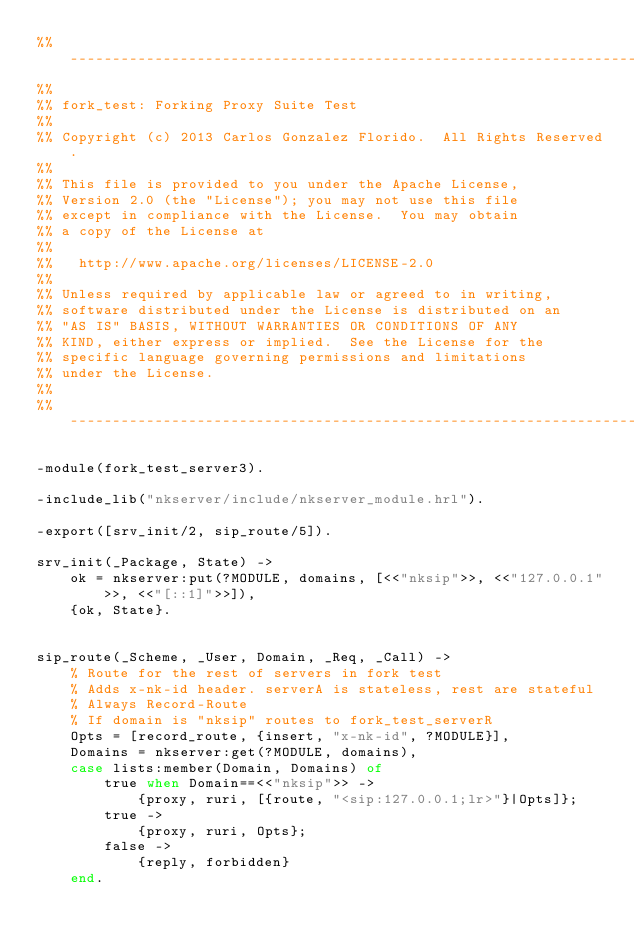Convert code to text. <code><loc_0><loc_0><loc_500><loc_500><_Erlang_>%% -------------------------------------------------------------------
%%
%% fork_test: Forking Proxy Suite Test
%%
%% Copyright (c) 2013 Carlos Gonzalez Florido.  All Rights Reserved.
%%
%% This file is provided to you under the Apache License,
%% Version 2.0 (the "License"); you may not use this file
%% except in compliance with the License.  You may obtain
%% a copy of the License at
%%
%%   http://www.apache.org/licenses/LICENSE-2.0
%%
%% Unless required by applicable law or agreed to in writing,
%% software distributed under the License is distributed on an
%% "AS IS" BASIS, WITHOUT WARRANTIES OR CONDITIONS OF ANY
%% KIND, either express or implied.  See the License for the
%% specific language governing permissions and limitations
%% under the License.
%%
%% -------------------------------------------------------------------

-module(fork_test_server3).

-include_lib("nkserver/include/nkserver_module.hrl").

-export([srv_init/2, sip_route/5]).

srv_init(_Package, State) ->
    ok = nkserver:put(?MODULE, domains, [<<"nksip">>, <<"127.0.0.1">>, <<"[::1]">>]),
    {ok, State}.


sip_route(_Scheme, _User, Domain, _Req, _Call) ->
    % Route for the rest of servers in fork test
    % Adds x-nk-id header. serverA is stateless, rest are stateful
    % Always Record-Route
    % If domain is "nksip" routes to fork_test_serverR
    Opts = [record_route, {insert, "x-nk-id", ?MODULE}],
    Domains = nkserver:get(?MODULE, domains),
    case lists:member(Domain, Domains) of
        true when Domain==<<"nksip">> ->
            {proxy, ruri, [{route, "<sip:127.0.0.1;lr>"}|Opts]};
        true ->
            {proxy, ruri, Opts};
        false ->
            {reply, forbidden}
    end.

</code> 